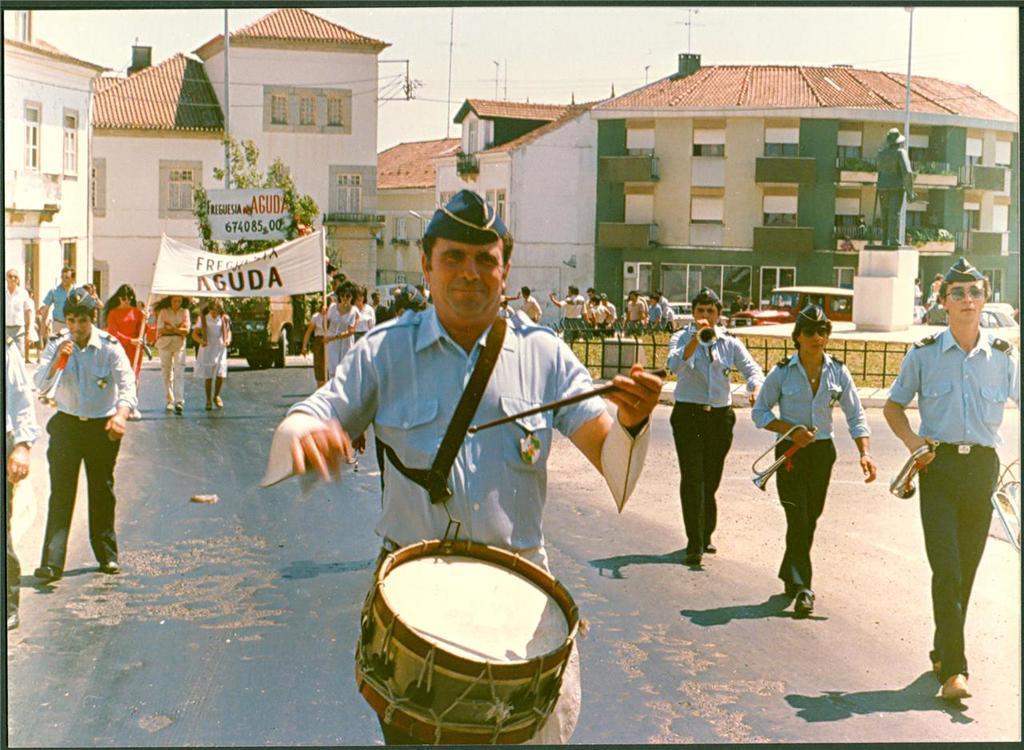How would you summarize this image in a sentence or two? In this image there are group of people walking on the road. In front the man is playing the drum. At the back side we can see a building and a sky. The person is holding a banner. On the road there are vehicles in front of the road there is a statue. 